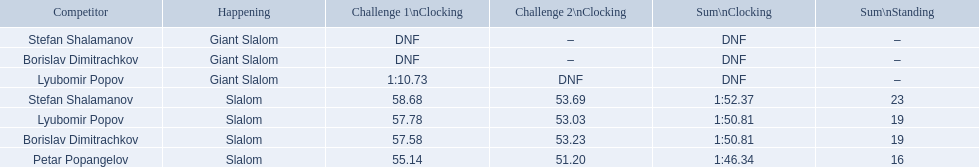What were the event names during bulgaria at the 1988 winter olympics? Stefan Shalamanov, Borislav Dimitrachkov, Lyubomir Popov. And which players participated at giant slalom? Giant Slalom, Giant Slalom, Giant Slalom, Slalom, Slalom, Slalom, Slalom. What were their race 1 times? DNF, DNF, 1:10.73. What was lyubomir popov's personal time? 1:10.73. 